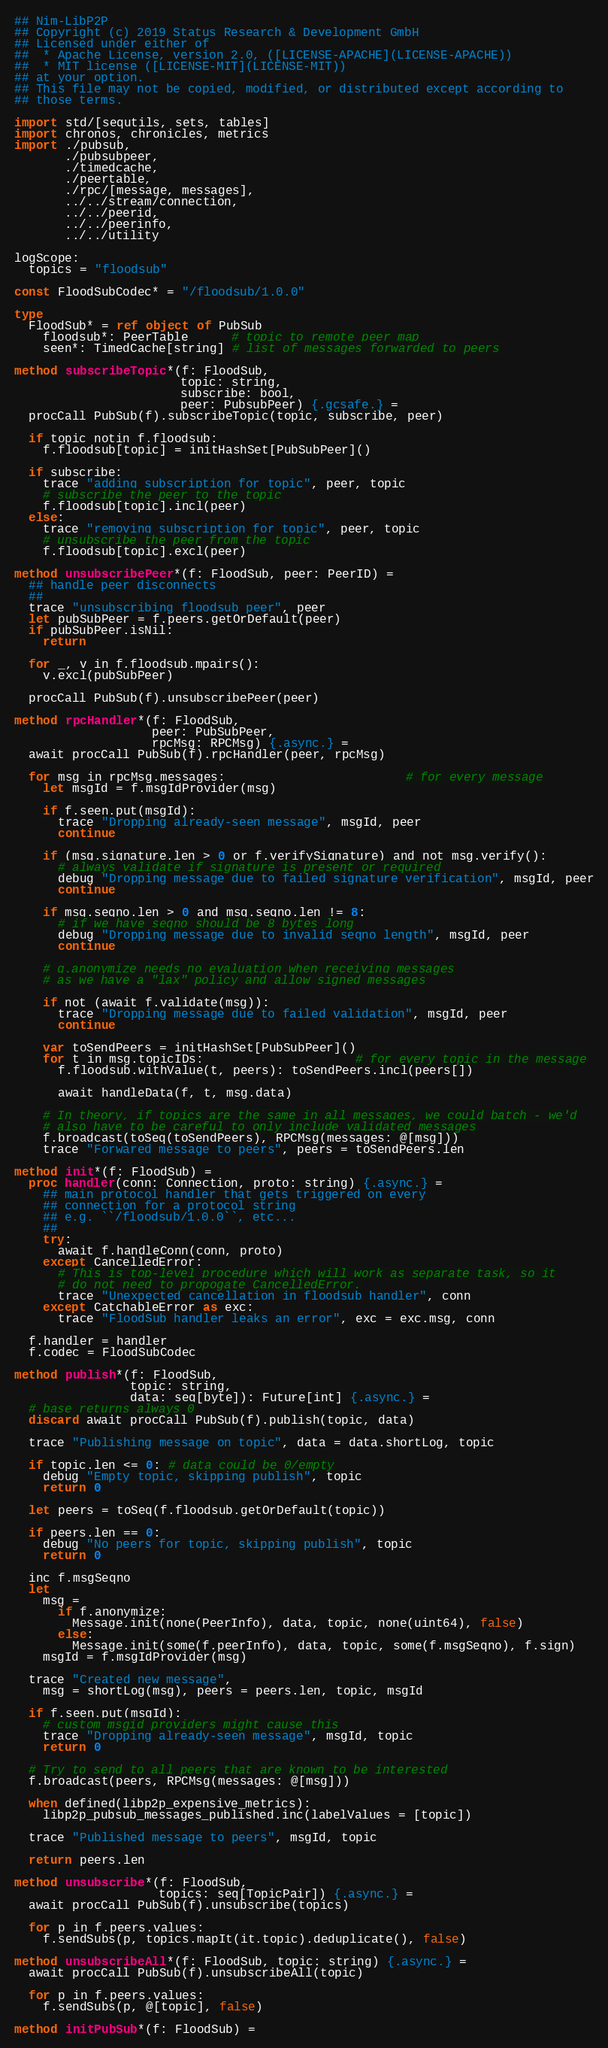Convert code to text. <code><loc_0><loc_0><loc_500><loc_500><_Nim_>## Nim-LibP2P
## Copyright (c) 2019 Status Research & Development GmbH
## Licensed under either of
##  * Apache License, version 2.0, ([LICENSE-APACHE](LICENSE-APACHE))
##  * MIT license ([LICENSE-MIT](LICENSE-MIT))
## at your option.
## This file may not be copied, modified, or distributed except according to
## those terms.

import std/[sequtils, sets, tables]
import chronos, chronicles, metrics
import ./pubsub,
       ./pubsubpeer,
       ./timedcache,
       ./peertable,
       ./rpc/[message, messages],
       ../../stream/connection,
       ../../peerid,
       ../../peerinfo,
       ../../utility

logScope:
  topics = "floodsub"

const FloodSubCodec* = "/floodsub/1.0.0"

type
  FloodSub* = ref object of PubSub
    floodsub*: PeerTable      # topic to remote peer map
    seen*: TimedCache[string] # list of messages forwarded to peers

method subscribeTopic*(f: FloodSub,
                       topic: string,
                       subscribe: bool,
                       peer: PubsubPeer) {.gcsafe.} =
  procCall PubSub(f).subscribeTopic(topic, subscribe, peer)

  if topic notin f.floodsub:
    f.floodsub[topic] = initHashSet[PubSubPeer]()

  if subscribe:
    trace "adding subscription for topic", peer, topic
    # subscribe the peer to the topic
    f.floodsub[topic].incl(peer)
  else:
    trace "removing subscription for topic", peer, topic
    # unsubscribe the peer from the topic
    f.floodsub[topic].excl(peer)

method unsubscribePeer*(f: FloodSub, peer: PeerID) =
  ## handle peer disconnects
  ##
  trace "unsubscribing floodsub peer", peer
  let pubSubPeer = f.peers.getOrDefault(peer)
  if pubSubPeer.isNil:
    return

  for _, v in f.floodsub.mpairs():
    v.excl(pubSubPeer)

  procCall PubSub(f).unsubscribePeer(peer)

method rpcHandler*(f: FloodSub,
                   peer: PubSubPeer,
                   rpcMsg: RPCMsg) {.async.} =
  await procCall PubSub(f).rpcHandler(peer, rpcMsg)

  for msg in rpcMsg.messages:                         # for every message
    let msgId = f.msgIdProvider(msg)

    if f.seen.put(msgId):
      trace "Dropping already-seen message", msgId, peer
      continue

    if (msg.signature.len > 0 or f.verifySignature) and not msg.verify():
      # always validate if signature is present or required
      debug "Dropping message due to failed signature verification", msgId, peer
      continue

    if msg.seqno.len > 0 and msg.seqno.len != 8:
      # if we have seqno should be 8 bytes long
      debug "Dropping message due to invalid seqno length", msgId, peer
      continue

    # g.anonymize needs no evaluation when receiving messages
    # as we have a "lax" policy and allow signed messages

    if not (await f.validate(msg)):
      trace "Dropping message due to failed validation", msgId, peer
      continue

    var toSendPeers = initHashSet[PubSubPeer]()
    for t in msg.topicIDs:                     # for every topic in the message
      f.floodsub.withValue(t, peers): toSendPeers.incl(peers[])

      await handleData(f, t, msg.data)

    # In theory, if topics are the same in all messages, we could batch - we'd
    # also have to be careful to only include validated messages
    f.broadcast(toSeq(toSendPeers), RPCMsg(messages: @[msg]))
    trace "Forwared message to peers", peers = toSendPeers.len

method init*(f: FloodSub) =
  proc handler(conn: Connection, proto: string) {.async.} =
    ## main protocol handler that gets triggered on every
    ## connection for a protocol string
    ## e.g. ``/floodsub/1.0.0``, etc...
    ##
    try:
      await f.handleConn(conn, proto)
    except CancelledError:
      # This is top-level procedure which will work as separate task, so it
      # do not need to propogate CancelledError.
      trace "Unexpected cancellation in floodsub handler", conn
    except CatchableError as exc:
      trace "FloodSub handler leaks an error", exc = exc.msg, conn

  f.handler = handler
  f.codec = FloodSubCodec

method publish*(f: FloodSub,
                topic: string,
                data: seq[byte]): Future[int] {.async.} =
  # base returns always 0
  discard await procCall PubSub(f).publish(topic, data)

  trace "Publishing message on topic", data = data.shortLog, topic

  if topic.len <= 0: # data could be 0/empty
    debug "Empty topic, skipping publish", topic
    return 0

  let peers = toSeq(f.floodsub.getOrDefault(topic))

  if peers.len == 0:
    debug "No peers for topic, skipping publish", topic
    return 0

  inc f.msgSeqno
  let
    msg =
      if f.anonymize:
        Message.init(none(PeerInfo), data, topic, none(uint64), false)
      else:
        Message.init(some(f.peerInfo), data, topic, some(f.msgSeqno), f.sign)
    msgId = f.msgIdProvider(msg)

  trace "Created new message",
    msg = shortLog(msg), peers = peers.len, topic, msgId

  if f.seen.put(msgId):
    # custom msgid providers might cause this
    trace "Dropping already-seen message", msgId, topic
    return 0

  # Try to send to all peers that are known to be interested
  f.broadcast(peers, RPCMsg(messages: @[msg]))

  when defined(libp2p_expensive_metrics):
    libp2p_pubsub_messages_published.inc(labelValues = [topic])

  trace "Published message to peers", msgId, topic

  return peers.len

method unsubscribe*(f: FloodSub,
                    topics: seq[TopicPair]) {.async.} =
  await procCall PubSub(f).unsubscribe(topics)

  for p in f.peers.values:
    f.sendSubs(p, topics.mapIt(it.topic).deduplicate(), false)

method unsubscribeAll*(f: FloodSub, topic: string) {.async.} =
  await procCall PubSub(f).unsubscribeAll(topic)

  for p in f.peers.values:
    f.sendSubs(p, @[topic], false)

method initPubSub*(f: FloodSub) =</code> 